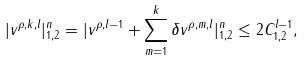<formula> <loc_0><loc_0><loc_500><loc_500>| v ^ { \rho , k , l } | ^ { n } _ { 1 , 2 } = | v ^ { \rho , l - 1 } + \sum _ { m = 1 } ^ { k } \delta v ^ { \rho , m , l } | ^ { n } _ { 1 , 2 } \leq 2 C ^ { l - 1 } _ { 1 , 2 } ,</formula> 